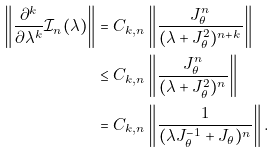<formula> <loc_0><loc_0><loc_500><loc_500>\left \| \frac { \partial ^ { k } } { \partial \lambda ^ { k } } \mathcal { I } _ { n } ( \lambda ) \right \| & = C _ { k , n } \left \| \frac { J _ { \theta } ^ { n } } { ( \lambda + J _ { \theta } ^ { 2 } ) ^ { n + k } } \right \| \\ & \leq C _ { k , n } \left \| \frac { J _ { \theta } ^ { n } } { ( \lambda + J _ { \theta } ^ { 2 } ) ^ { n } } \right \| \\ & = C _ { k , n } \left \| \frac { 1 } { ( \lambda J _ { \theta } ^ { - 1 } + J _ { \theta } ) ^ { n } } \right \| .</formula> 